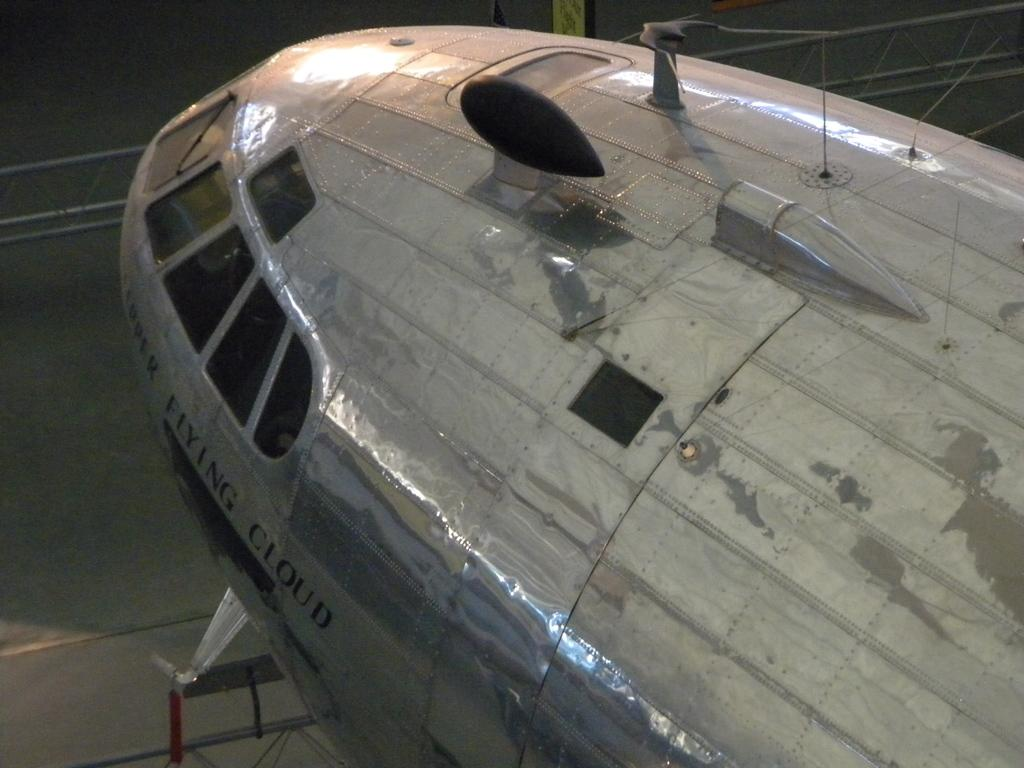<image>
Present a compact description of the photo's key features. An airplane covered in steel plating is named after a cloud. 